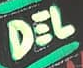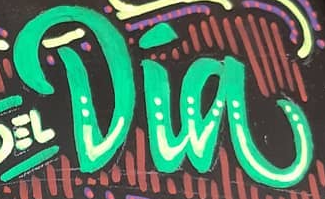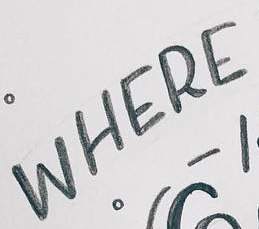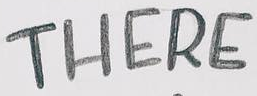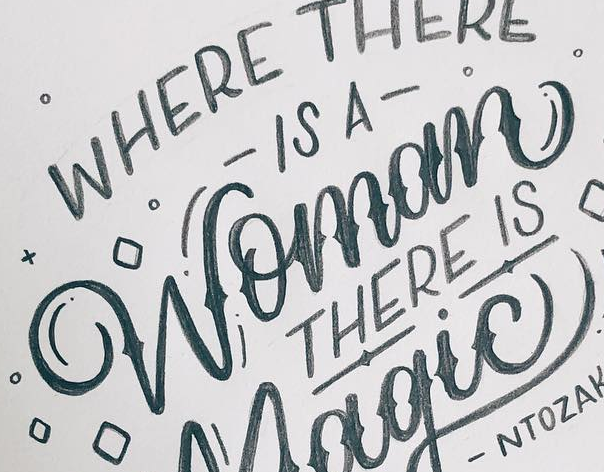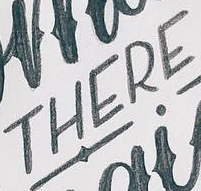Identify the words shown in these images in order, separated by a semicolon. DEL; Dia; WHERE; THERE; Womom; THERE 